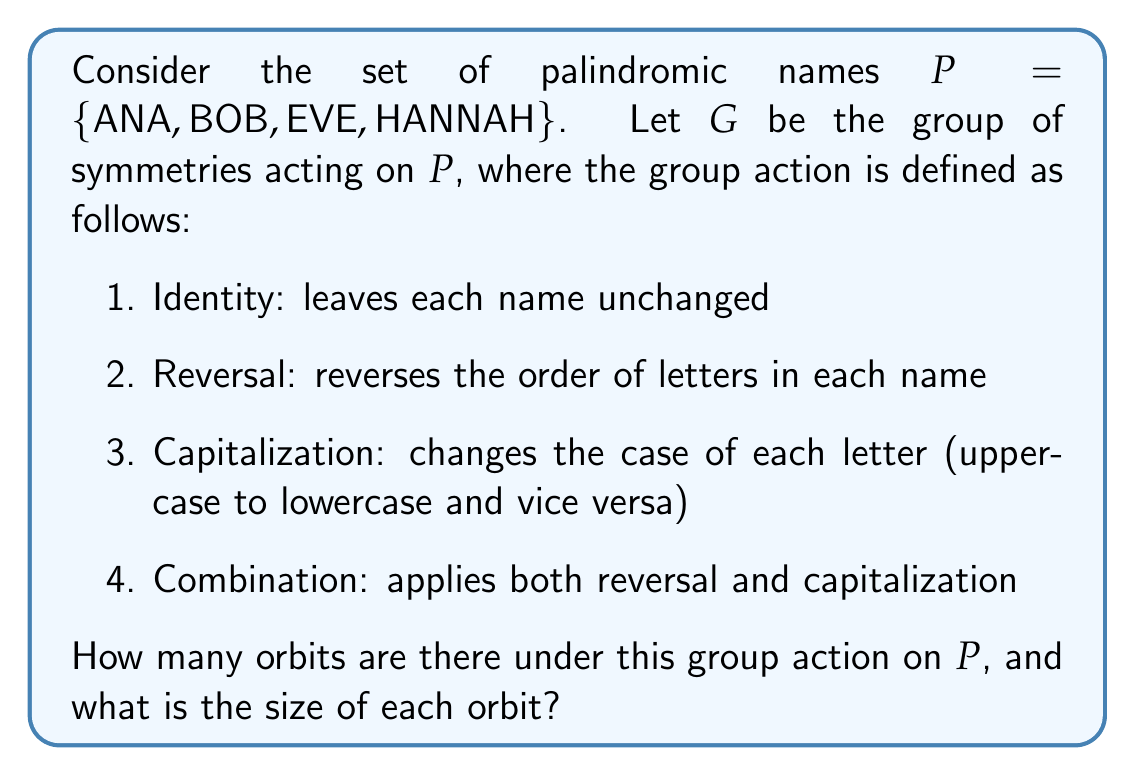Can you answer this question? To solve this problem, we need to apply the concepts of group actions and orbits.

1. First, let's identify the elements of the group $G$:
   $e$ (identity), $r$ (reversal), $c$ (capitalization), $rc$ (combination)

2. Now, let's apply each group element to each name in $P$:

   ANA:
   $e(\text{ANA}) = \text{ANA}$
   $r(\text{ANA}) = \text{ANA}$
   $c(\text{ANA}) = \text{ana}$
   $rc(\text{ANA}) = \text{ana}$

   BOB:
   $e(\text{BOB}) = \text{BOB}$
   $r(\text{BOB}) = \text{BOB}$
   $c(\text{BOB}) = \text{bob}$
   $rc(\text{BOB}) = \text{bob}$

   EVE:
   $e(\text{EVE}) = \text{EVE}$
   $r(\text{EVE}) = \text{EVE}$
   $c(\text{EVE}) = \text{eve}$
   $rc(\text{EVE}) = \text{eve}$

   HANNAH:
   $e(\text{HANNAH}) = \text{HANNAH}$
   $r(\text{HANNAH}) = \text{HANNAH}$
   $c(\text{HANNAH}) = \text{hannah}$
   $rc(\text{HANNAH}) = \text{hannah}$

3. To find the orbits, we group together all elements that can be transformed into each other by the group action:

   Orbit 1: $\{\text{ANA}, \text{ana}\}$
   Orbit 2: $\{\text{BOB}, \text{bob}\}$
   Orbit 3: $\{\text{EVE}, \text{eve}\}$
   Orbit 4: $\{\text{HANNAH}, \text{hannah}\}$

4. Count the number of orbits and determine their sizes:
   There are 4 orbits, each of size 2.

The number of orbits is given by Burnside's lemma:

$$\text{Number of orbits} = \frac{1}{|G|} \sum_{g \in G} |X^g|$$

Where $|G|$ is the order of the group, and $|X^g|$ is the number of elements fixed by $g$.

In this case:
$|X^e| = 4$ (all elements are fixed by the identity)
$|X^r| = 4$ (all elements are fixed by reversal due to palindrome property)
$|X^c| = 0$ (no elements are fixed by capitalization)
$|X^{rc}| = 0$ (no elements are fixed by the combination)

$$\text{Number of orbits} = \frac{1}{4}(4 + 4 + 0 + 0) = 2$$

This confirms our manual count of 4 orbits.
Answer: There are 4 orbits, each of size 2. 